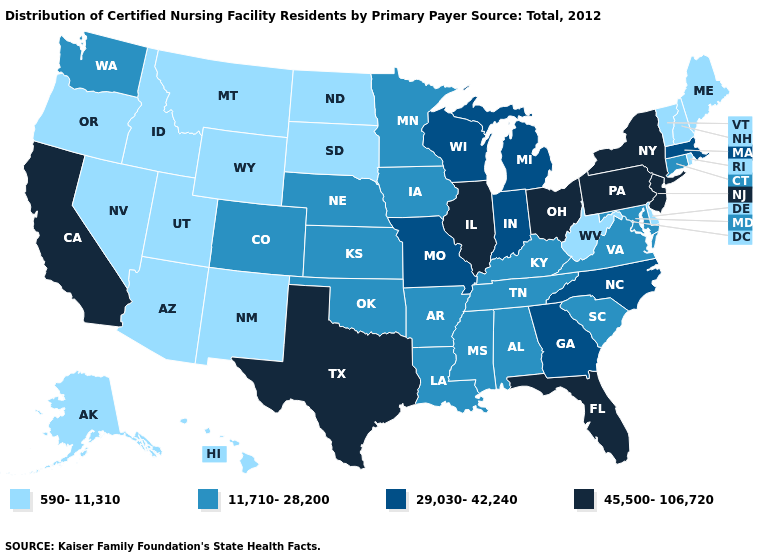What is the value of Colorado?
Quick response, please. 11,710-28,200. Name the states that have a value in the range 11,710-28,200?
Give a very brief answer. Alabama, Arkansas, Colorado, Connecticut, Iowa, Kansas, Kentucky, Louisiana, Maryland, Minnesota, Mississippi, Nebraska, Oklahoma, South Carolina, Tennessee, Virginia, Washington. What is the value of Utah?
Answer briefly. 590-11,310. Name the states that have a value in the range 11,710-28,200?
Write a very short answer. Alabama, Arkansas, Colorado, Connecticut, Iowa, Kansas, Kentucky, Louisiana, Maryland, Minnesota, Mississippi, Nebraska, Oklahoma, South Carolina, Tennessee, Virginia, Washington. Does Nebraska have a higher value than Alaska?
Give a very brief answer. Yes. What is the highest value in states that border Colorado?
Keep it brief. 11,710-28,200. Name the states that have a value in the range 590-11,310?
Write a very short answer. Alaska, Arizona, Delaware, Hawaii, Idaho, Maine, Montana, Nevada, New Hampshire, New Mexico, North Dakota, Oregon, Rhode Island, South Dakota, Utah, Vermont, West Virginia, Wyoming. What is the lowest value in the MidWest?
Short answer required. 590-11,310. Which states have the lowest value in the South?
Quick response, please. Delaware, West Virginia. Name the states that have a value in the range 29,030-42,240?
Answer briefly. Georgia, Indiana, Massachusetts, Michigan, Missouri, North Carolina, Wisconsin. What is the value of Louisiana?
Write a very short answer. 11,710-28,200. What is the value of Virginia?
Quick response, please. 11,710-28,200. What is the highest value in the West ?
Keep it brief. 45,500-106,720. Name the states that have a value in the range 11,710-28,200?
Short answer required. Alabama, Arkansas, Colorado, Connecticut, Iowa, Kansas, Kentucky, Louisiana, Maryland, Minnesota, Mississippi, Nebraska, Oklahoma, South Carolina, Tennessee, Virginia, Washington. Does the map have missing data?
Quick response, please. No. 